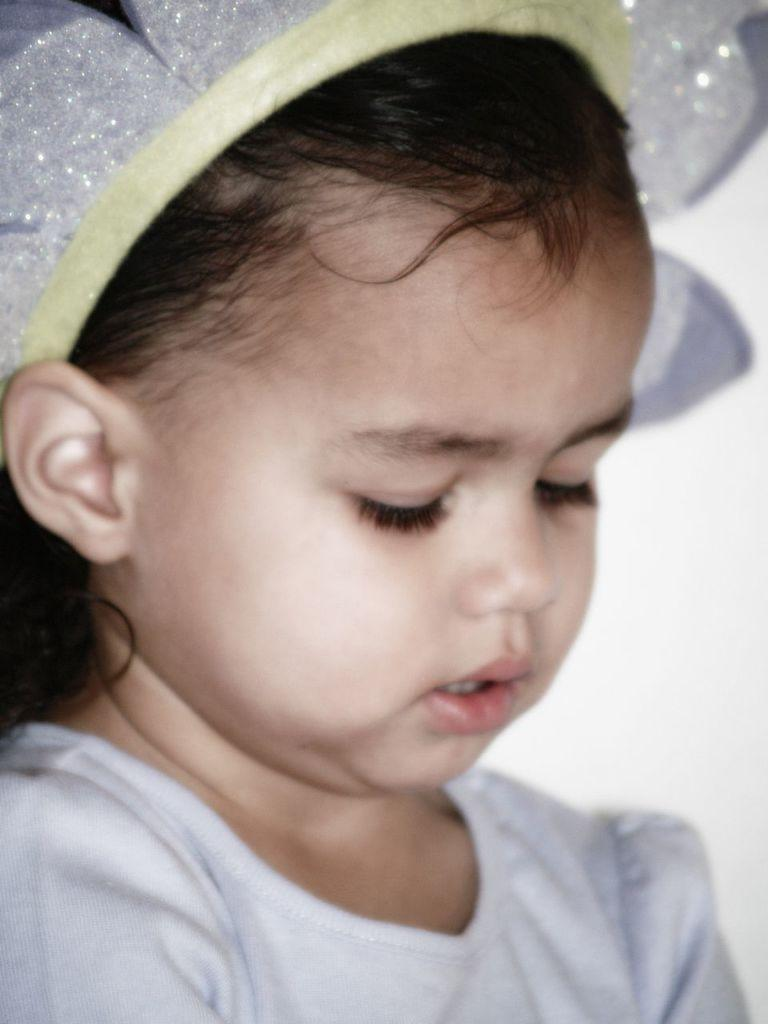What is the main subject of the image? The main subject of the image is a baby. Can you describe what the baby is wearing? The baby is wearing a white top. Is there any accessory visible on the baby's head? Yes, the baby has a white clip over her head. Where is the desk located in the image? There is no desk present in the image. What type of sofa can be seen in the image? There is no sofa present in the image. 